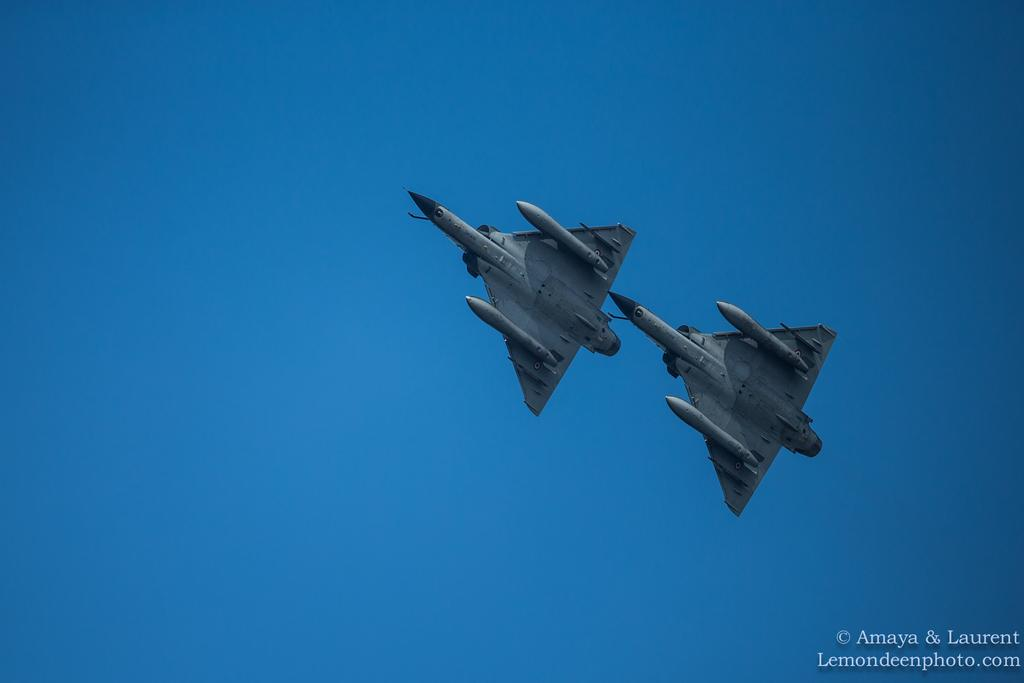<image>
Summarize the visual content of the image. The picture shown here is from the website Lemondeepphoto.com 